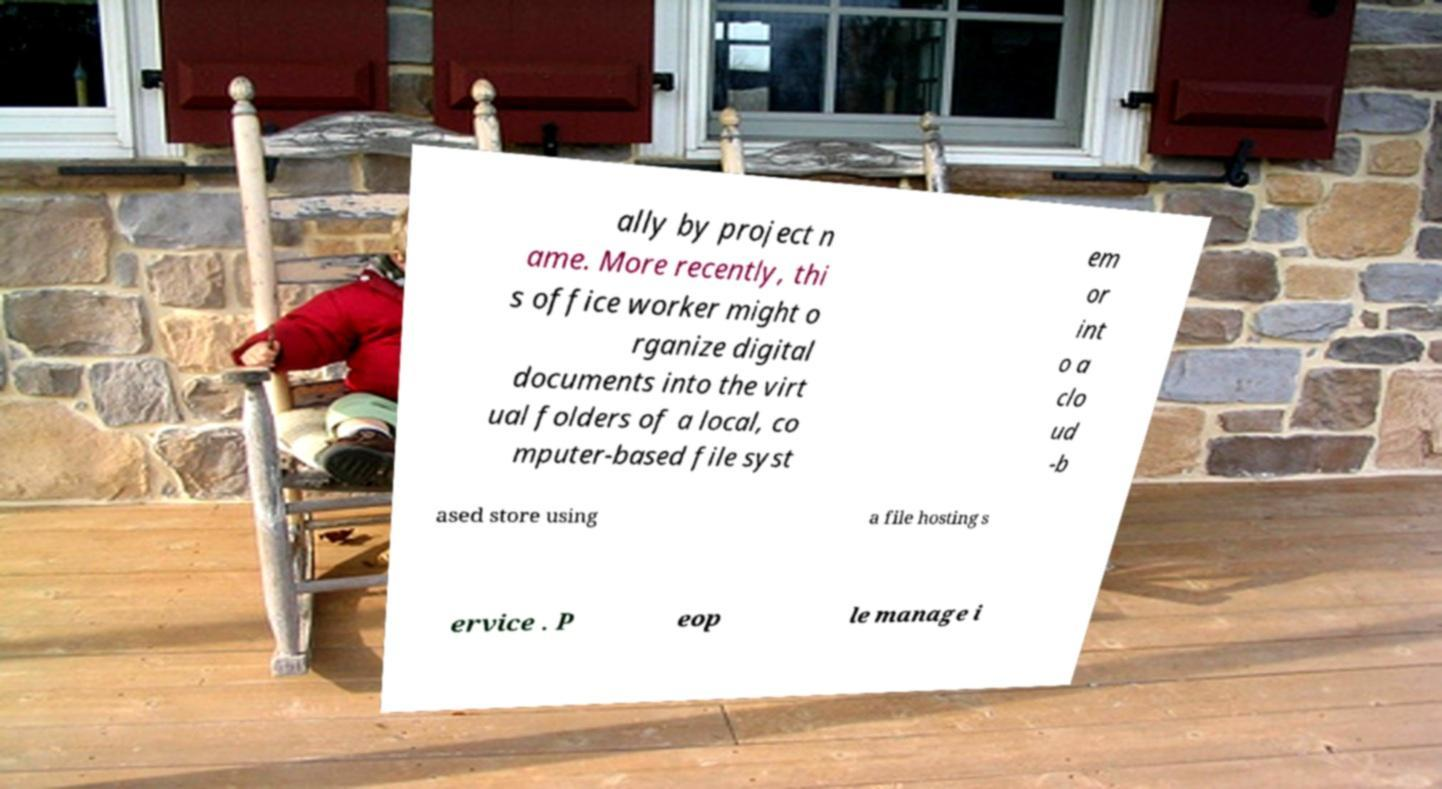What messages or text are displayed in this image? I need them in a readable, typed format. ally by project n ame. More recently, thi s office worker might o rganize digital documents into the virt ual folders of a local, co mputer-based file syst em or int o a clo ud -b ased store using a file hosting s ervice . P eop le manage i 